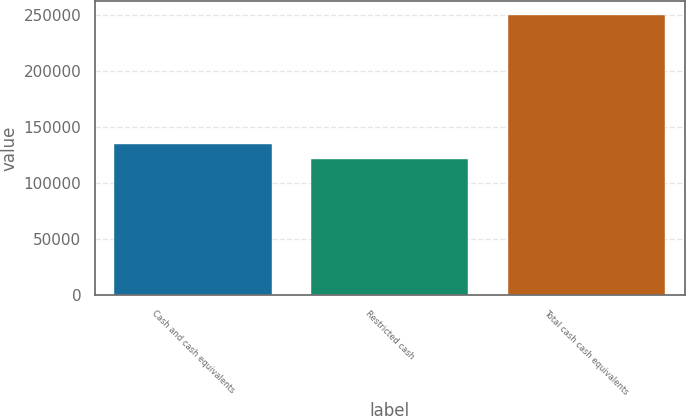Convert chart to OTSL. <chart><loc_0><loc_0><loc_500><loc_500><bar_chart><fcel>Cash and cash equivalents<fcel>Restricted cash<fcel>Total cash cash equivalents<nl><fcel>134927<fcel>122138<fcel>250026<nl></chart> 